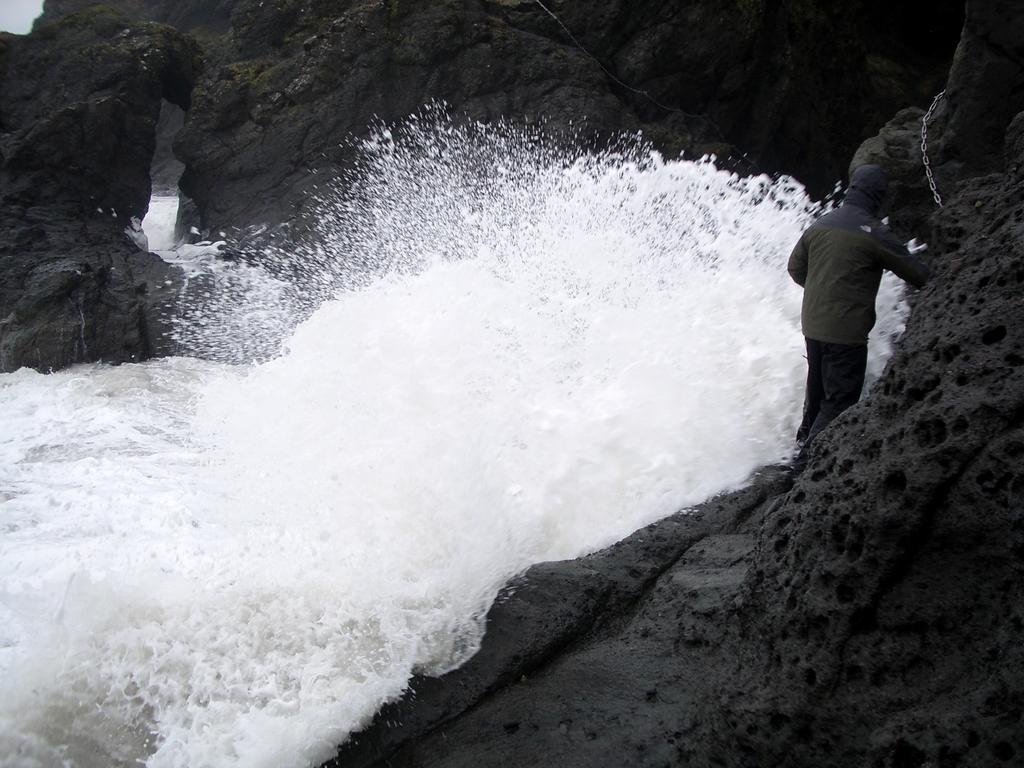What is the primary element present in the image? There is water in the image. What other objects can be seen in the image? There are stones in the image. Is there a person present in the image? Yes, there is a person standing in the image. What is the person wearing? The person is wearing a jacket. How many kittens can be seen playing with the smoke in the image? There are no kittens or smoke present in the image. What direction is the wind blowing in the image? There is no wind present in the image. 